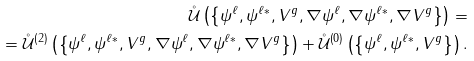Convert formula to latex. <formula><loc_0><loc_0><loc_500><loc_500>\mathcal { \mathring { U } } \left ( \left \{ \psi ^ { \ell } , \psi ^ { \ell \ast } , V ^ { g } , \nabla \psi ^ { \ell } , \nabla \psi ^ { \ell \ast } , \nabla V ^ { g } \right \} \right ) = \\ = \mathcal { \mathring { U } } ^ { \left ( 2 \right ) } \left ( \left \{ \psi ^ { \ell } , \psi ^ { \ell \ast } , V ^ { g } , \nabla \psi ^ { \ell } , \nabla \psi ^ { \ell \ast } , \nabla V ^ { g } \right \} \right ) + \mathcal { \mathring { U } } ^ { \left ( 0 \right ) } \left ( \left \{ \psi ^ { \ell } , \psi ^ { \ell \ast } , V ^ { g } \right \} \right ) .</formula> 